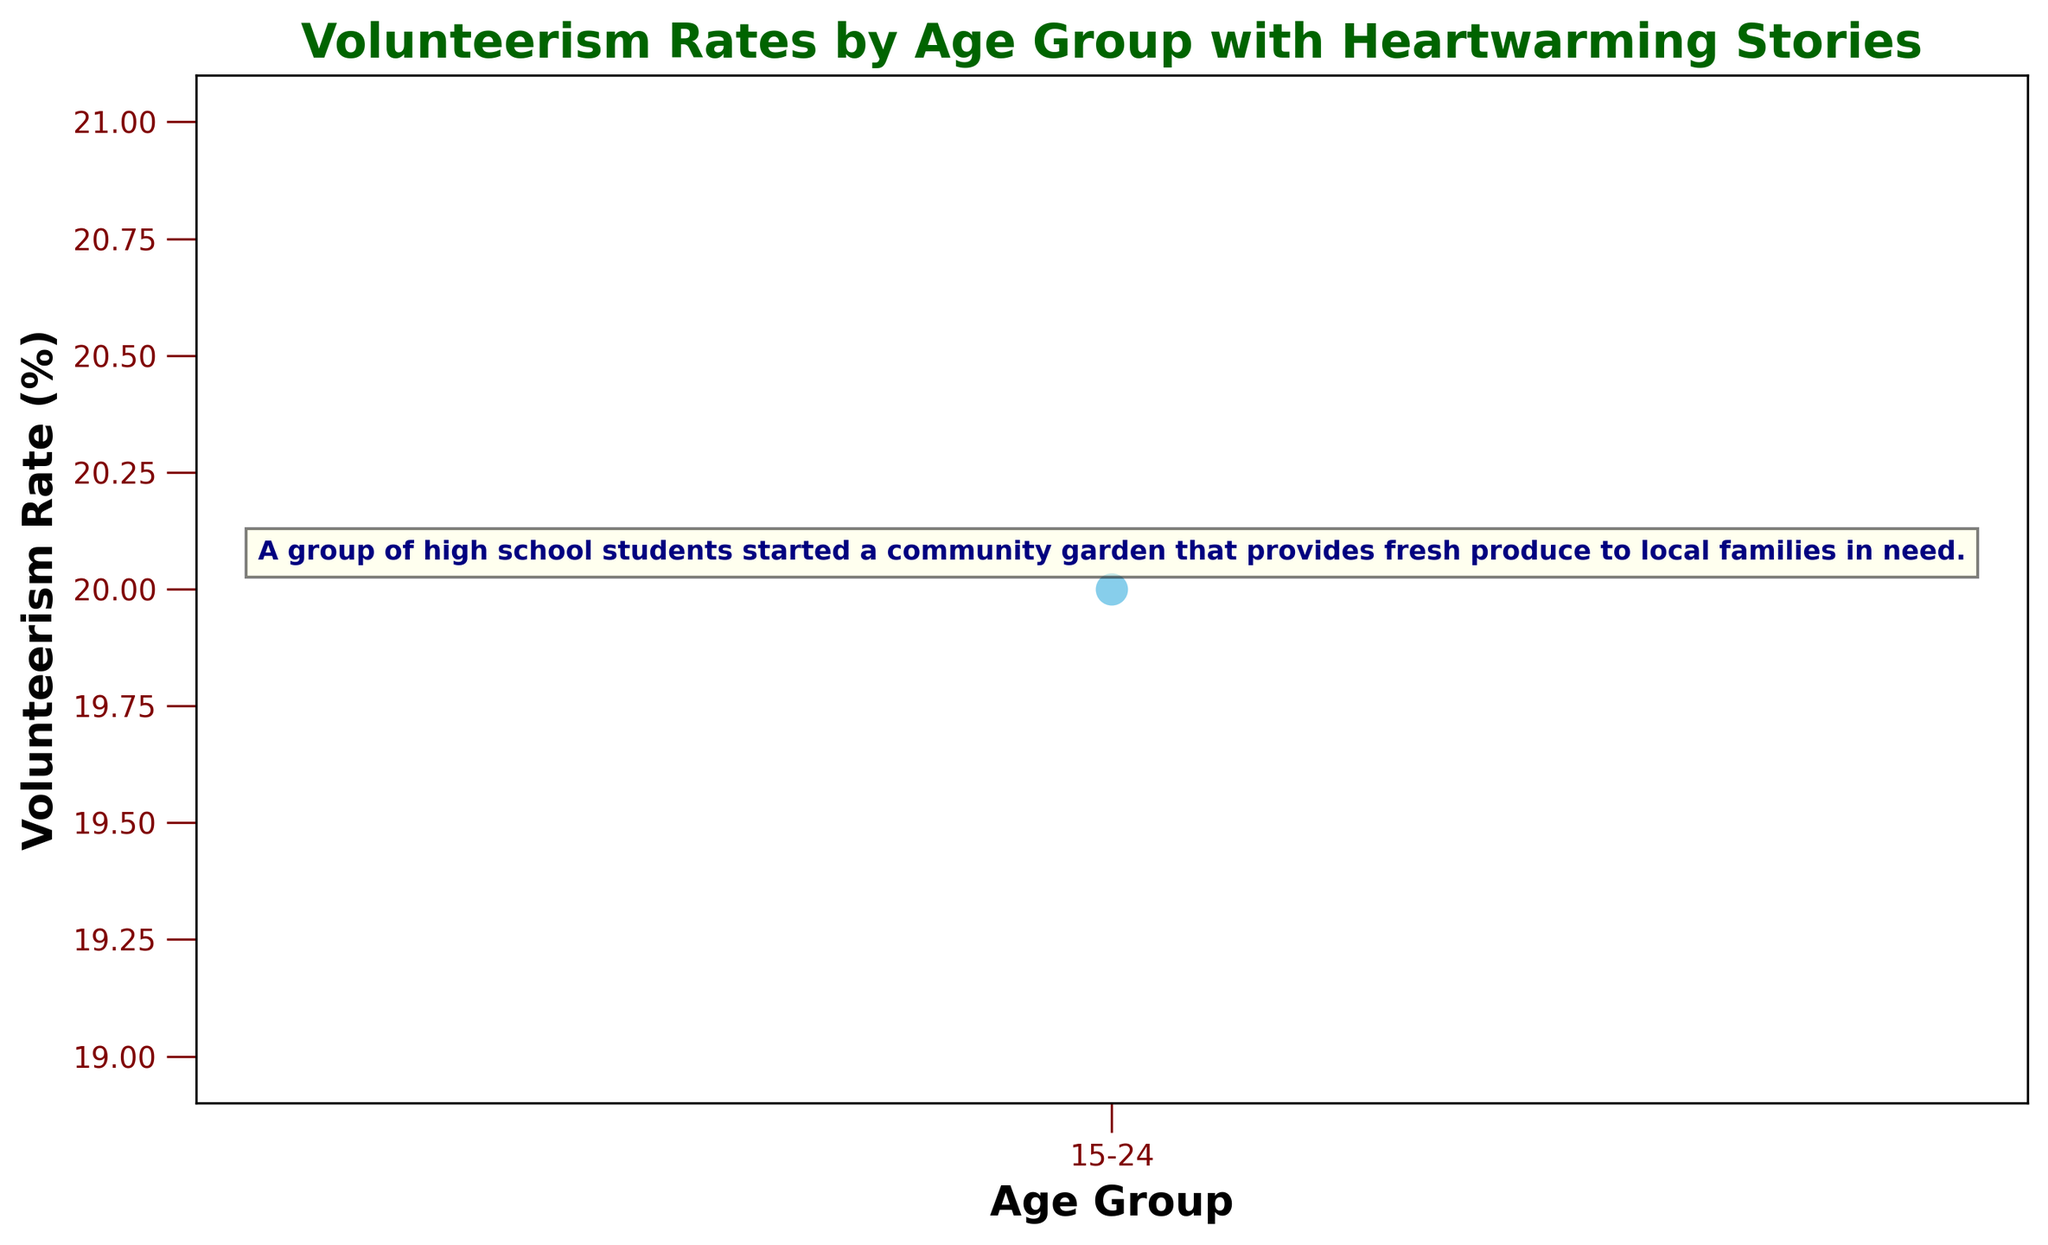What is the volunteerism rate for the 15-24 age group? The volunteerism rate for the 15-24 age group is directly annotated on the chart next to the data point. It shows 20%.
Answer: 20% Can you describe the heartwarming story related to the 15-24 age group? The heartwarming story is textually annotated on the chart near the 15-24 age group data point. It reads: "A group of high school students started a community garden that provides fresh produce to local families in need."
Answer: A group of high school students started a community garden that provides fresh produce to local families in need What is the color of the line used for plotting the volunteerism rates? Looking at the chart, the line used to plot the volunteerism rates is visually identified by its color. It is a sky blue line.
Answer: Sky blue How is the volunteerism rate represented in the chart? The volunteerism rate is represented as a series of data points connected by a dashed line. Each point is marked with a circle.
Answer: Data points and dashed line How is the heartwarming story annotated on the chart? The heartwarming story is annotated using text with a navy color and bold font. It is positioned above the data point for the 15-24 age group with a light yellow background inside a box.
Answer: Navy text, light yellow boxed background What font color and style are used for the title of the chart? The title of the chart is written in a dark green color with bold font style.
Answer: Dark green, bold What are the colors used for the x-axis and y-axis tick labels? The colors of the tick labels on both the x-axis and y-axis are maroon.
Answer: Maroon How do the annotations ensure they are easy to read in terms of their positioning? The annotations for the heartwarming stories are positioned just above the data points using offset points, specifically 10 points above (xytext=(0,10)), ensuring they do not overlap with other elements of the chart and are easily readable.
Answer: Above data points, 10 points offset What descriptive text is used for the x-axis label? The descriptive text for the x-axis label is "Age Group".
Answer: Age Group What descriptive text is used for the y-axis label? The descriptive text for the y-axis label is "Volunteerism Rate (%)".
Answer: Volunteerism Rate (%) 